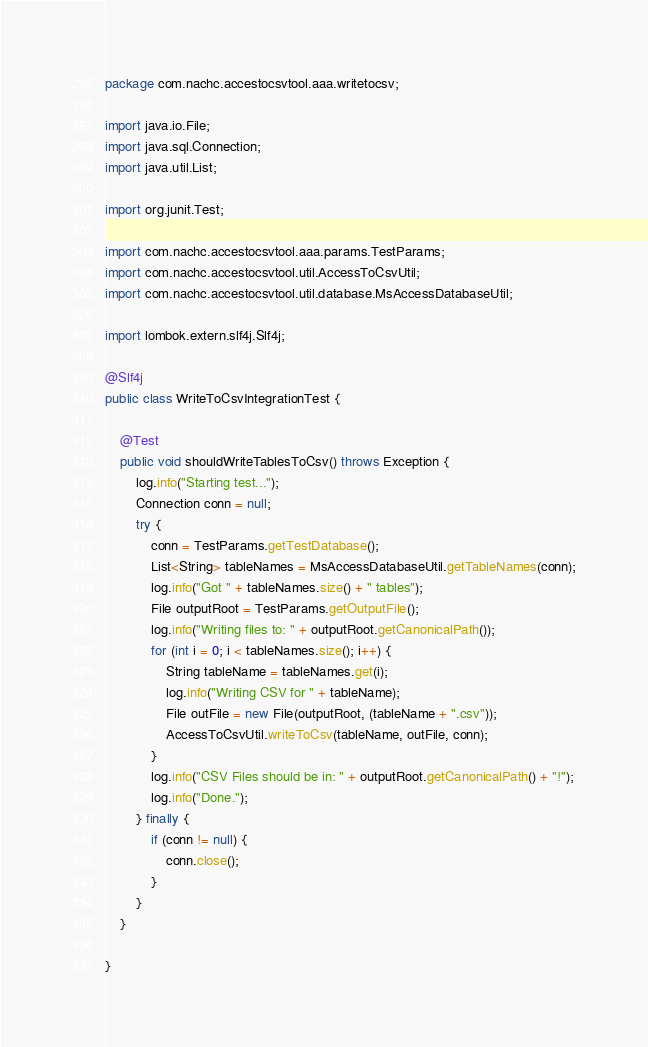<code> <loc_0><loc_0><loc_500><loc_500><_Java_>package com.nachc.accestocsvtool.aaa.writetocsv;

import java.io.File;
import java.sql.Connection;
import java.util.List;

import org.junit.Test;

import com.nachc.accestocsvtool.aaa.params.TestParams;
import com.nachc.accestocsvtool.util.AccessToCsvUtil;
import com.nachc.accestocsvtool.util.database.MsAccessDatabaseUtil;

import lombok.extern.slf4j.Slf4j;

@Slf4j
public class WriteToCsvIntegrationTest {

	@Test
	public void shouldWriteTablesToCsv() throws Exception {
		log.info("Starting test...");
		Connection conn = null;
		try {
			conn = TestParams.getTestDatabase();
			List<String> tableNames = MsAccessDatabaseUtil.getTableNames(conn);
			log.info("Got " + tableNames.size() + " tables");
			File outputRoot = TestParams.getOutputFile();
			log.info("Writing files to: " + outputRoot.getCanonicalPath());
			for (int i = 0; i < tableNames.size(); i++) {
				String tableName = tableNames.get(i);
				log.info("Writing CSV for " + tableName);
				File outFile = new File(outputRoot, (tableName + ".csv"));
				AccessToCsvUtil.writeToCsv(tableName, outFile, conn);
			}
			log.info("CSV Files should be in: " + outputRoot.getCanonicalPath() + "!");
			log.info("Done.");
		} finally {
			if (conn != null) {
				conn.close();
			}
		}
	}

}
</code> 